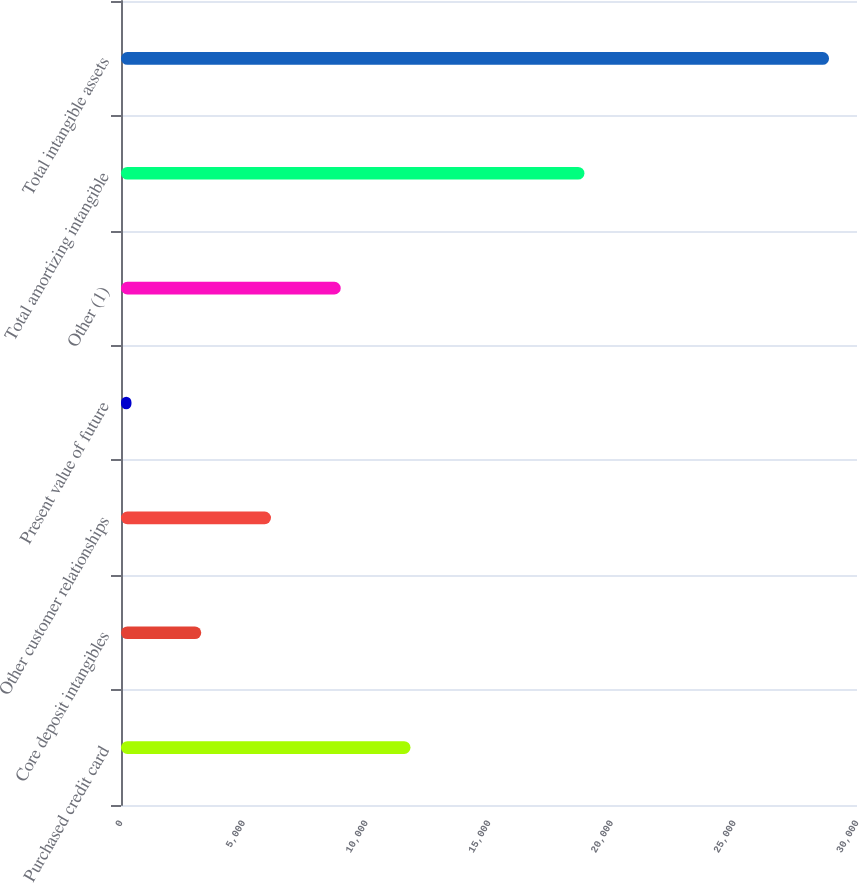Convert chart. <chart><loc_0><loc_0><loc_500><loc_500><bar_chart><fcel>Purchased credit card<fcel>Core deposit intangibles<fcel>Other customer relationships<fcel>Present value of future<fcel>Other (1)<fcel>Total amortizing intangible<fcel>Total intangible assets<nl><fcel>11800.6<fcel>3270.4<fcel>6113.8<fcel>427<fcel>8957.2<fcel>18890<fcel>28861<nl></chart> 